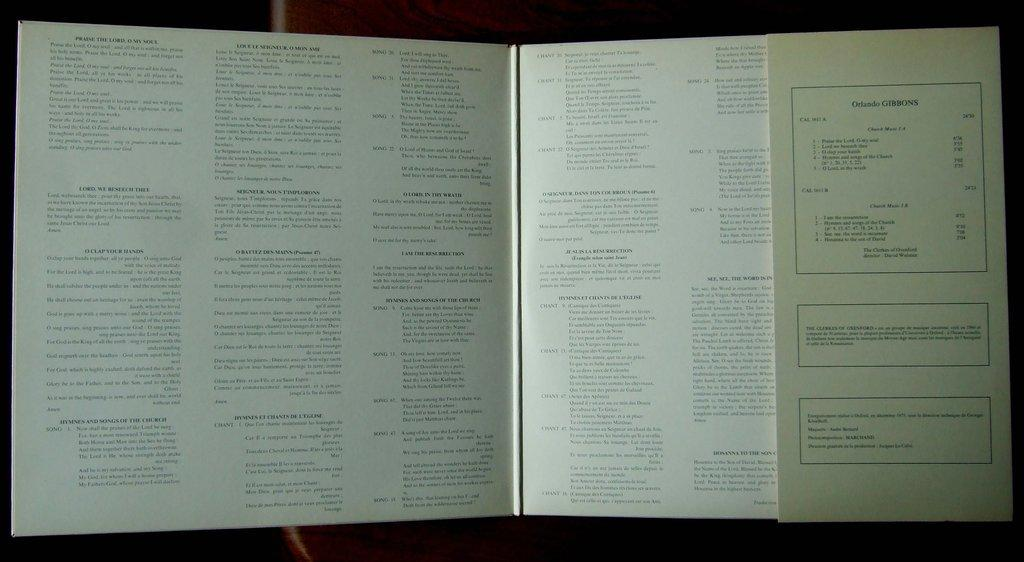<image>
Present a compact description of the photo's key features. A box on the right side of an open page says "Orlando GIBBONS" at the top. 